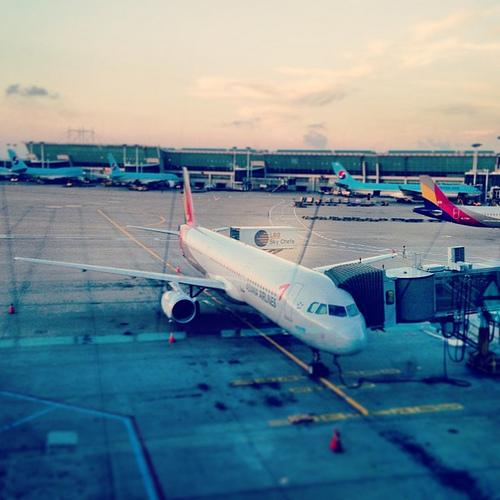Describe the state of the white airplane. The white airplane is on the ground, waiting for passengers, with a gate attached to it for passengers to board or disembark. What is the color of the plane with a Pepsi logo on it? The plane with a Pepsi logo is blue. Provide a brief description of the scene captured in the image. The image shows an airport tarmac with a white airplane with a red tail, a blue Pepsi airplane, and three blue planes in the background, and an orange caution cone and yellow lines on the ground. How many planes are visible in the image? There are at least five planes visible in the image. Explain the sentiment or atmosphere present in the image. The atmosphere in the image is busy and energetic, depicting typical airport activity with planes preparing for take-off or disembarking passengers. Mention the different colors present in the airplane tail fins. The tail fins have colors like white, red, blue, yellow, and a combination of blue, yellow, and red on a tail fin. Describe the object that may be associated with road safety in the image. An orange caution cone is present on the ground, which may be associated with road safety. What are the colors and company name present on the Pepsi airplane? The Pepsi airplane is blue with a white Pepsi logo. Mention the objects on the ground near the blue Pepsi airplane. There is an orange caution cone and yellow lines on the pavement near the blue Pepsi airplane. What can be seen in the sky within the image? Clouds are visible in the sky, which appears to be colorfully tinted with shades of pink and white. 